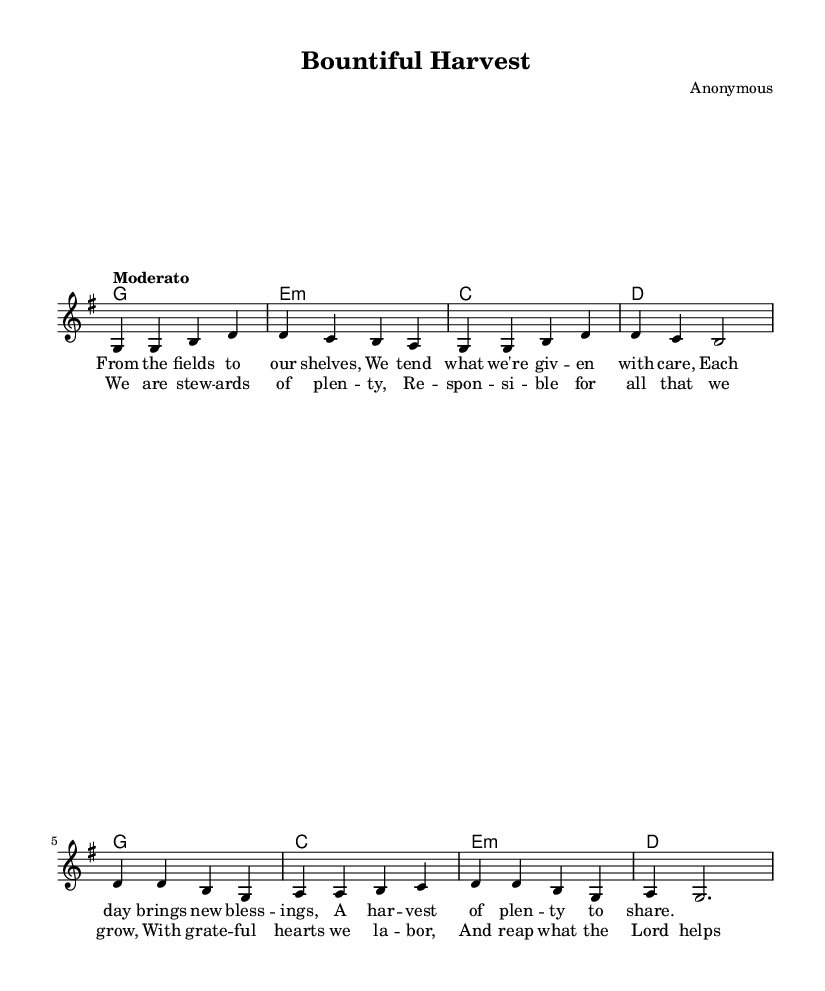What is the key signature of this music? The key signature is indicated by the presence of one sharp, which signifies G major or E minor. In this case, it is G major.
Answer: G major What is the time signature of this music? The time signature is located at the beginning of the staff, showing how many beats are in each measure. It indicates 4 beats per measure, which is shown as 4/4.
Answer: 4/4 What is the tempo marking for this music? The tempo marking is provided within the score, stating "Moderato," which indicates a moderate speed for performance.
Answer: Moderato How many measures are in the chorus? By counting the sections of the score designated for the chorus, there are a total of 4 measures.
Answer: 4 What is the first note of the melody? The first note of the melody appears in the staff at the start of the verse, and it is a G.
Answer: G What is the last lyric of the verse? The last lyric is at the end of the verse lyrics section. It states "to share," which completes the lyrical line.
Answer: to share What type of song structure is present in this piece? The music has a familiar structure known as verse-chorus. It first presents the verse followed by the chorus.
Answer: Verse-Chorus 